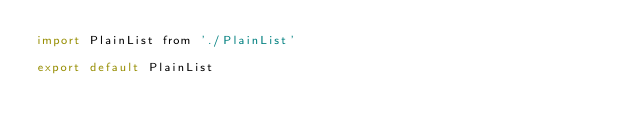Convert code to text. <code><loc_0><loc_0><loc_500><loc_500><_JavaScript_>import PlainList from './PlainList'

export default PlainList
</code> 